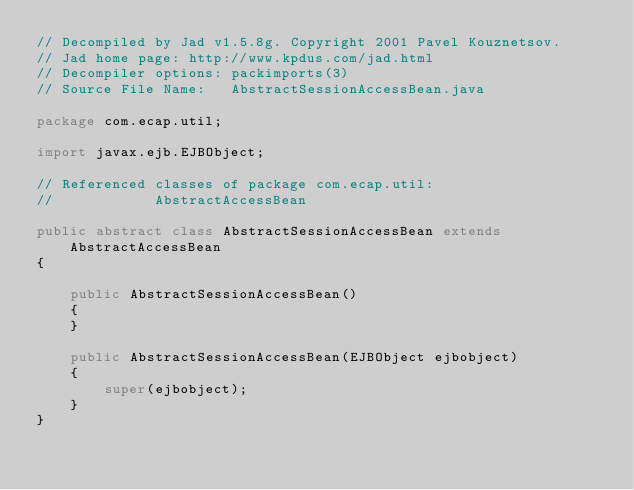Convert code to text. <code><loc_0><loc_0><loc_500><loc_500><_Java_>// Decompiled by Jad v1.5.8g. Copyright 2001 Pavel Kouznetsov.
// Jad home page: http://www.kpdus.com/jad.html
// Decompiler options: packimports(3) 
// Source File Name:   AbstractSessionAccessBean.java

package com.ecap.util;

import javax.ejb.EJBObject;

// Referenced classes of package com.ecap.util:
//            AbstractAccessBean

public abstract class AbstractSessionAccessBean extends AbstractAccessBean
{

    public AbstractSessionAccessBean()
    {
    }

    public AbstractSessionAccessBean(EJBObject ejbobject)
    {
        super(ejbobject);
    }
}
</code> 